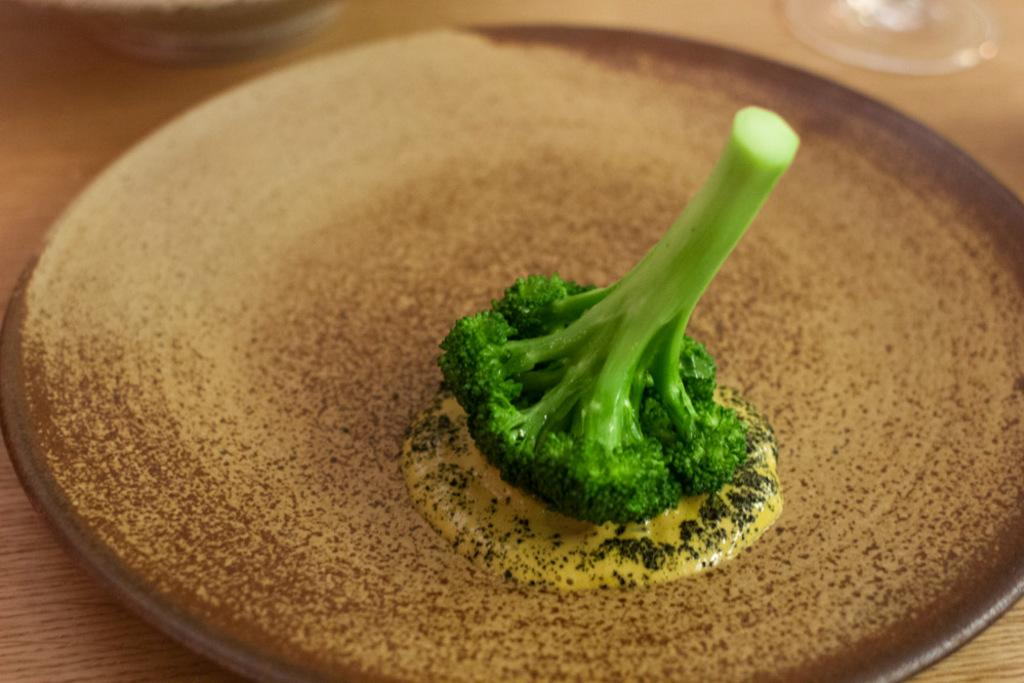What type of vegetable is on the plate in the image? There is a broccoli on a plate in the image. What type of road can be seen in the image? There is no road present in the image; it only features a broccoli on a plate. What type of field is visible in the image? There is no field present in the image; it only features a broccoli on a plate. 